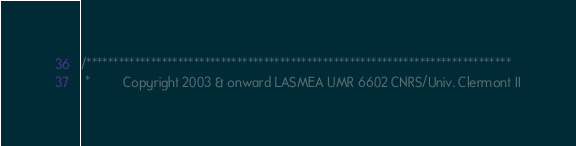<code> <loc_0><loc_0><loc_500><loc_500><_C++_>/*******************************************************************************
 *         Copyright 2003 & onward LASMEA UMR 6602 CNRS/Univ. Clermont II</code> 